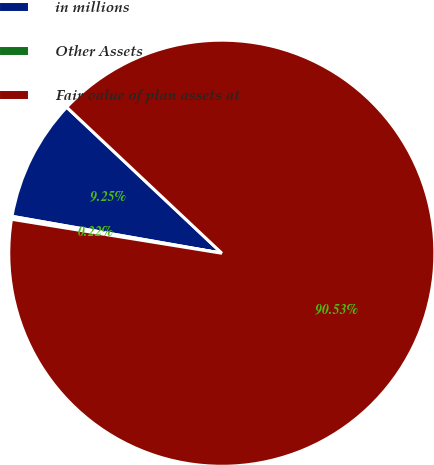Convert chart. <chart><loc_0><loc_0><loc_500><loc_500><pie_chart><fcel>in millions<fcel>Other Assets<fcel>Fair value of plan assets at<nl><fcel>9.25%<fcel>0.22%<fcel>90.53%<nl></chart> 